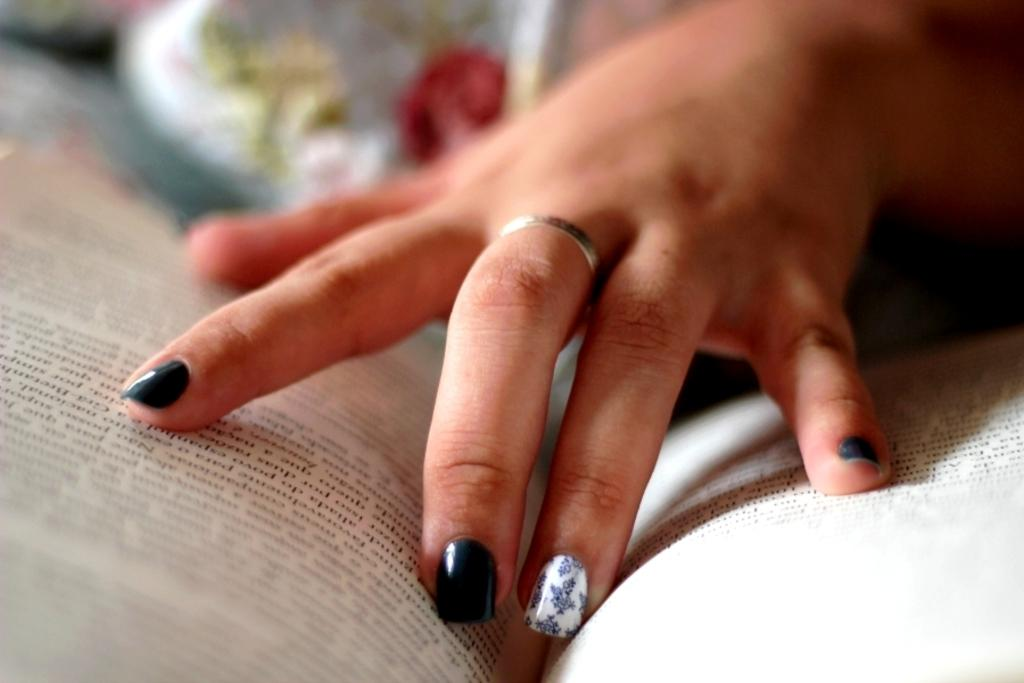What can be seen in the image? There is a person's hand in the image. What is the hand holding? The hand is holding a book. What is the weather like in the image? The provided facts do not mention any information about the weather, so it cannot be determined from the image. 